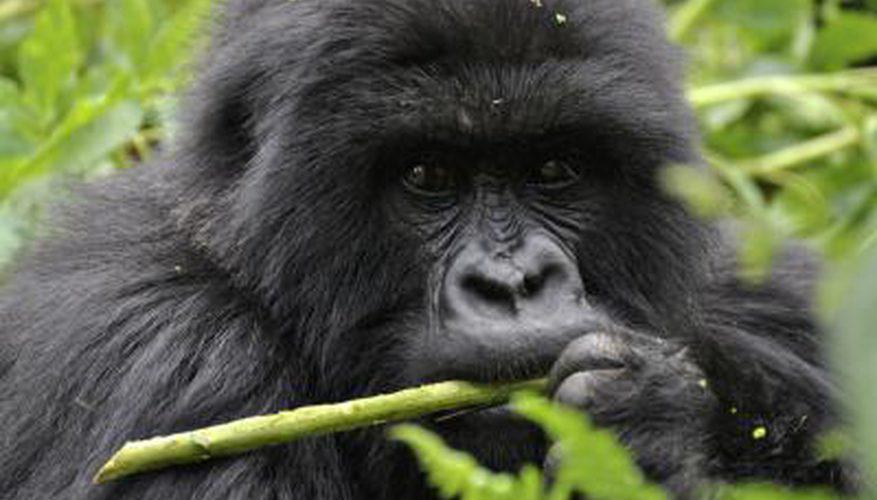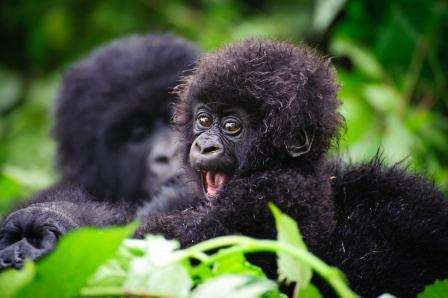The first image is the image on the left, the second image is the image on the right. Given the left and right images, does the statement "One of the images in the pair includes a baby gorilla." hold true? Answer yes or no. Yes. The first image is the image on the left, the second image is the image on the right. Analyze the images presented: Is the assertion "The left image shows one gorilla holding a leafless stalk to its mouth, and the right image includes a fuzzy-haired young gorilla looking over its shoulder toward the camera." valid? Answer yes or no. Yes. 